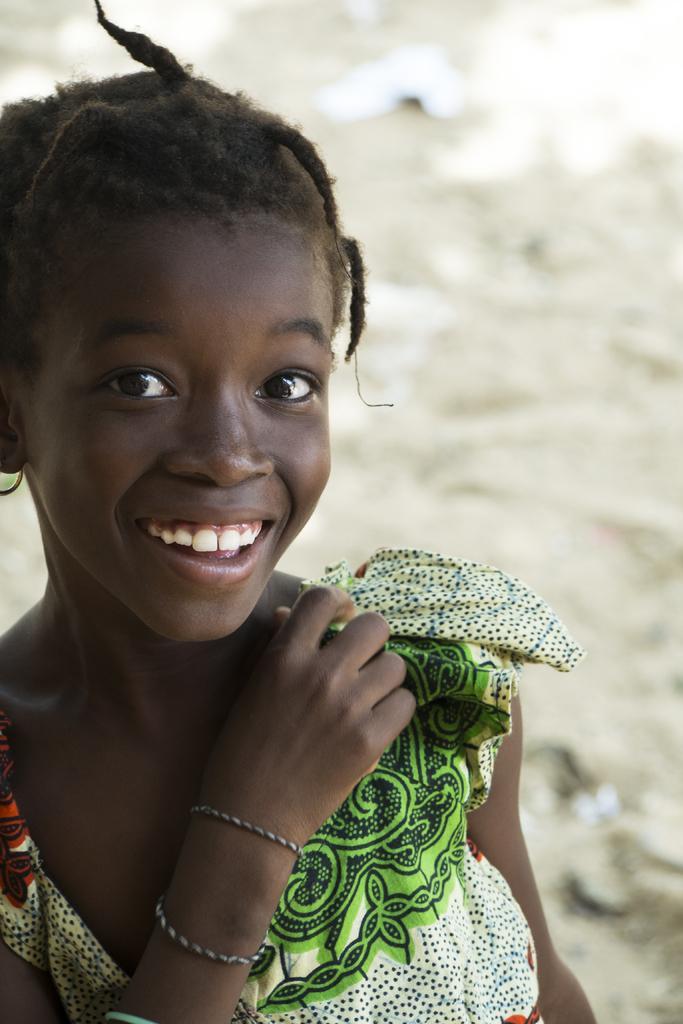What is the main subject of the image? There is a person in the image. Can you describe the person's attire? The person is wearing a dress with white, green, and black colors. What color is the background of the image? The background of the image is white. How many frogs are sitting on the person's head in the image? There are no frogs present in the image, so it is not possible to determine how many frogs might be sitting on the person's head. 